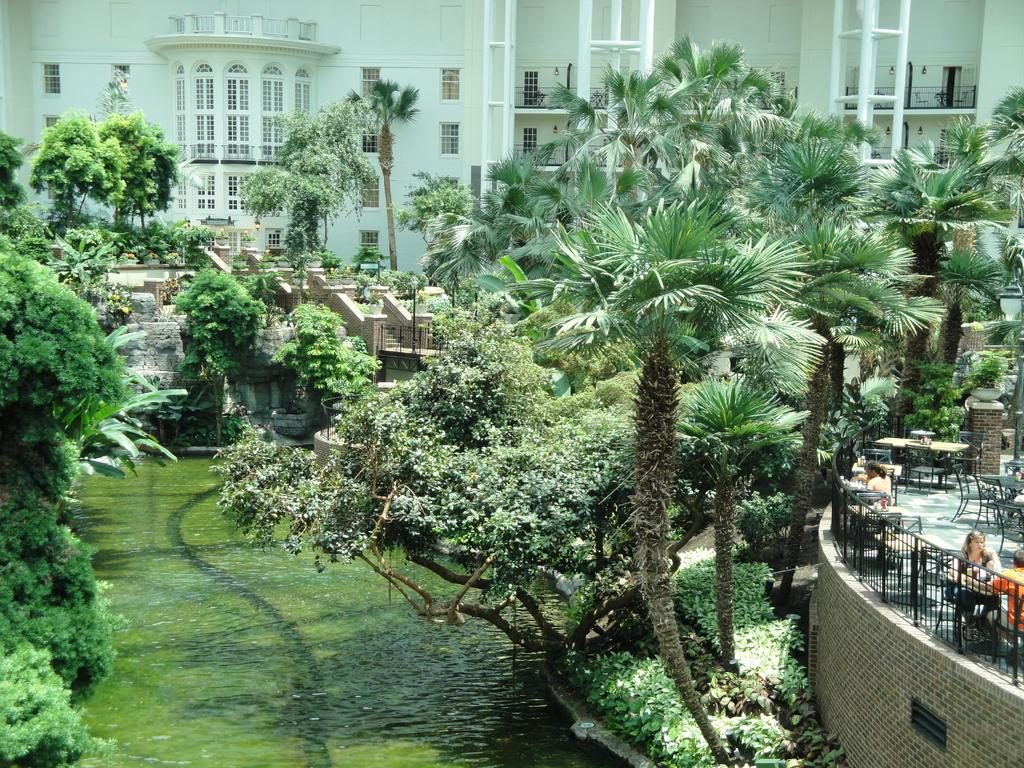What is the primary element visible in the image? There is water in the image. What type of natural vegetation can be seen in the image? There are trees in the image. What are the people in the image doing? There are persons sitting on chairs around tables on the right side of the image. What can be seen in the background of the image? There is a building in the background of the image. What type of bells can be heard ringing in the image? There are no bells present in the image, and therefore no sound can be heard. How many birds are visible in the image? There are no birds visible in the image. 